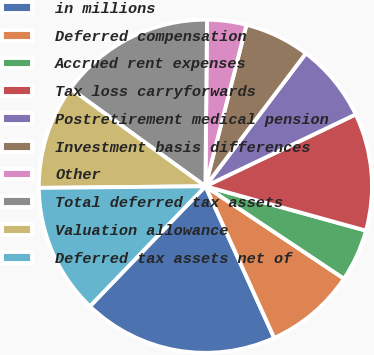Convert chart. <chart><loc_0><loc_0><loc_500><loc_500><pie_chart><fcel>in millions<fcel>Deferred compensation<fcel>Accrued rent expenses<fcel>Tax loss carryforwards<fcel>Postretirement medical pension<fcel>Investment basis differences<fcel>Other<fcel>Total deferred tax assets<fcel>Valuation allowance<fcel>Deferred tax assets net of<nl><fcel>18.97%<fcel>8.86%<fcel>5.07%<fcel>11.39%<fcel>7.6%<fcel>6.34%<fcel>3.81%<fcel>15.18%<fcel>10.13%<fcel>12.65%<nl></chart> 